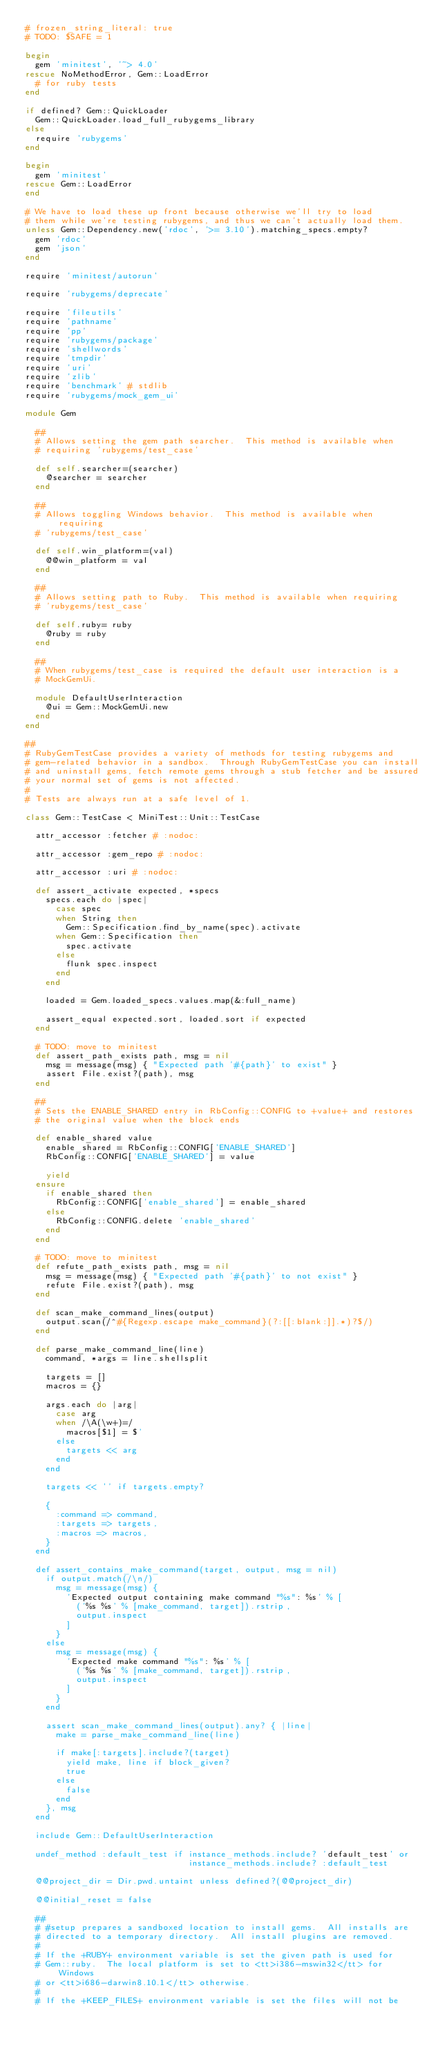<code> <loc_0><loc_0><loc_500><loc_500><_Ruby_># frozen_string_literal: true
# TODO: $SAFE = 1

begin
  gem 'minitest', '~> 4.0'
rescue NoMethodError, Gem::LoadError
  # for ruby tests
end

if defined? Gem::QuickLoader
  Gem::QuickLoader.load_full_rubygems_library
else
  require 'rubygems'
end

begin
  gem 'minitest'
rescue Gem::LoadError
end

# We have to load these up front because otherwise we'll try to load
# them while we're testing rubygems, and thus we can't actually load them.
unless Gem::Dependency.new('rdoc', '>= 3.10').matching_specs.empty?
  gem 'rdoc'
  gem 'json'
end

require 'minitest/autorun'

require 'rubygems/deprecate'

require 'fileutils'
require 'pathname'
require 'pp'
require 'rubygems/package'
require 'shellwords'
require 'tmpdir'
require 'uri'
require 'zlib'
require 'benchmark' # stdlib
require 'rubygems/mock_gem_ui'

module Gem

  ##
  # Allows setting the gem path searcher.  This method is available when
  # requiring 'rubygems/test_case'

  def self.searcher=(searcher)
    @searcher = searcher
  end

  ##
  # Allows toggling Windows behavior.  This method is available when requiring
  # 'rubygems/test_case'

  def self.win_platform=(val)
    @@win_platform = val
  end

  ##
  # Allows setting path to Ruby.  This method is available when requiring
  # 'rubygems/test_case'

  def self.ruby= ruby
    @ruby = ruby
  end

  ##
  # When rubygems/test_case is required the default user interaction is a
  # MockGemUi.

  module DefaultUserInteraction
    @ui = Gem::MockGemUi.new
  end
end

##
# RubyGemTestCase provides a variety of methods for testing rubygems and
# gem-related behavior in a sandbox.  Through RubyGemTestCase you can install
# and uninstall gems, fetch remote gems through a stub fetcher and be assured
# your normal set of gems is not affected.
#
# Tests are always run at a safe level of 1.

class Gem::TestCase < MiniTest::Unit::TestCase

  attr_accessor :fetcher # :nodoc:

  attr_accessor :gem_repo # :nodoc:

  attr_accessor :uri # :nodoc:

  def assert_activate expected, *specs
    specs.each do |spec|
      case spec
      when String then
        Gem::Specification.find_by_name(spec).activate
      when Gem::Specification then
        spec.activate
      else
        flunk spec.inspect
      end
    end

    loaded = Gem.loaded_specs.values.map(&:full_name)

    assert_equal expected.sort, loaded.sort if expected
  end

  # TODO: move to minitest
  def assert_path_exists path, msg = nil
    msg = message(msg) { "Expected path '#{path}' to exist" }
    assert File.exist?(path), msg
  end

  ##
  # Sets the ENABLE_SHARED entry in RbConfig::CONFIG to +value+ and restores
  # the original value when the block ends

  def enable_shared value
    enable_shared = RbConfig::CONFIG['ENABLE_SHARED']
    RbConfig::CONFIG['ENABLE_SHARED'] = value

    yield
  ensure
    if enable_shared then
      RbConfig::CONFIG['enable_shared'] = enable_shared
    else
      RbConfig::CONFIG.delete 'enable_shared'
    end
  end

  # TODO: move to minitest
  def refute_path_exists path, msg = nil
    msg = message(msg) { "Expected path '#{path}' to not exist" }
    refute File.exist?(path), msg
  end

  def scan_make_command_lines(output)
    output.scan(/^#{Regexp.escape make_command}(?:[[:blank:]].*)?$/)
  end

  def parse_make_command_line(line)
    command, *args = line.shellsplit

    targets = []
    macros = {}

    args.each do |arg|
      case arg
      when /\A(\w+)=/
        macros[$1] = $'
      else
        targets << arg
      end
    end

    targets << '' if targets.empty?

    {
      :command => command,
      :targets => targets,
      :macros => macros,
    }
  end

  def assert_contains_make_command(target, output, msg = nil)
    if output.match(/\n/)
      msg = message(msg) {
        'Expected output containing make command "%s": %s' % [
          ('%s %s' % [make_command, target]).rstrip,
          output.inspect
        ]
      }
    else
      msg = message(msg) {
        'Expected make command "%s": %s' % [
          ('%s %s' % [make_command, target]).rstrip,
          output.inspect
        ]
      }
    end

    assert scan_make_command_lines(output).any? { |line|
      make = parse_make_command_line(line)

      if make[:targets].include?(target)
        yield make, line if block_given?
        true
      else
        false
      end
    }, msg
  end

  include Gem::DefaultUserInteraction

  undef_method :default_test if instance_methods.include? 'default_test' or
                                instance_methods.include? :default_test

  @@project_dir = Dir.pwd.untaint unless defined?(@@project_dir)

  @@initial_reset = false

  ##
  # #setup prepares a sandboxed location to install gems.  All installs are
  # directed to a temporary directory.  All install plugins are removed.
  #
  # If the +RUBY+ environment variable is set the given path is used for
  # Gem::ruby.  The local platform is set to <tt>i386-mswin32</tt> for Windows
  # or <tt>i686-darwin8.10.1</tt> otherwise.
  #
  # If the +KEEP_FILES+ environment variable is set the files will not be</code> 